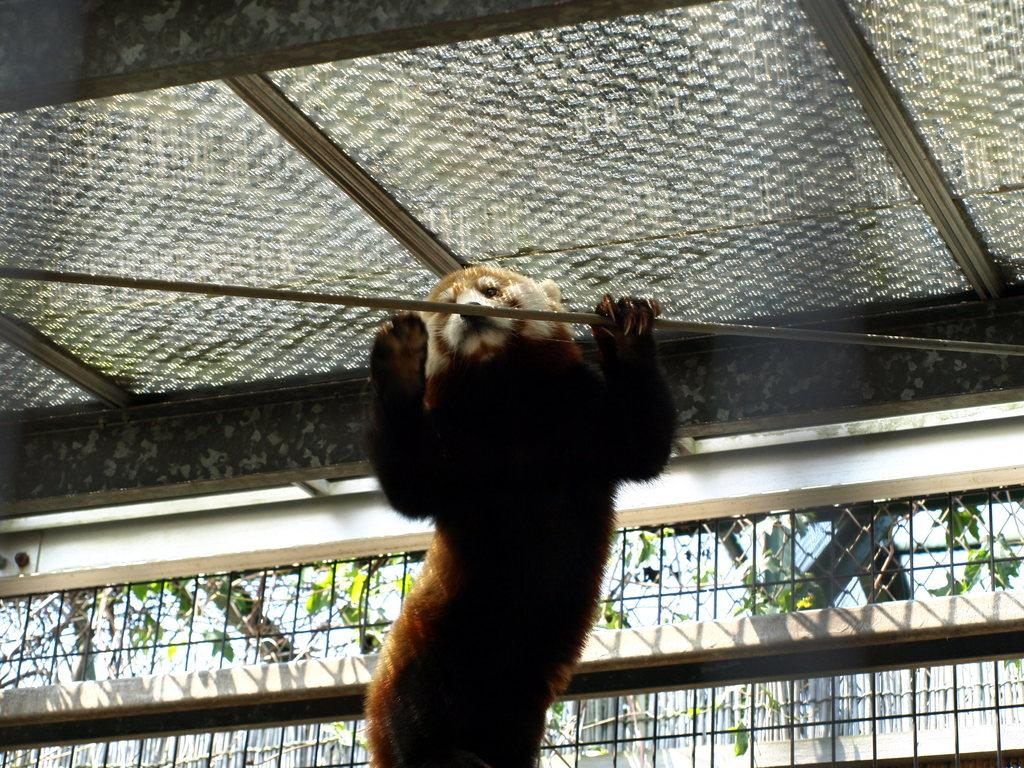What animal is present in the image? There is a bear in the image. What structure can be seen in the image? There is a fence in the image. Reasoning: Let's think step by step by step in order to produce the conversation. We start by identifying the main subject in the image, which is the bear. Then, we expand the conversation to include the fence, which is the only other object mentioned in the facts. Each question is designed to elicit a specific detail about the image that is known from the provided facts. Absurd Question/Answer: What type of faucet is visible in the image? There is no faucet present in the image. What kind of music can be heard playing in the background of the image? There is no music present in the image. 